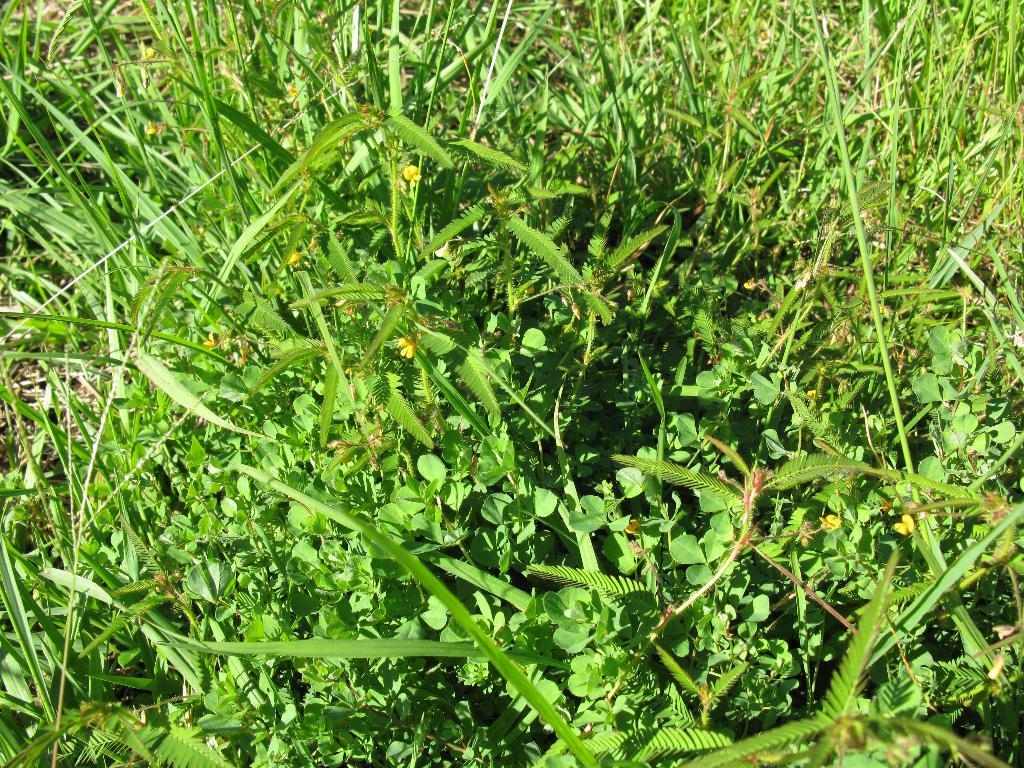Could you give a brief overview of what you see in this image? In this picture we can see grass and flowers. 